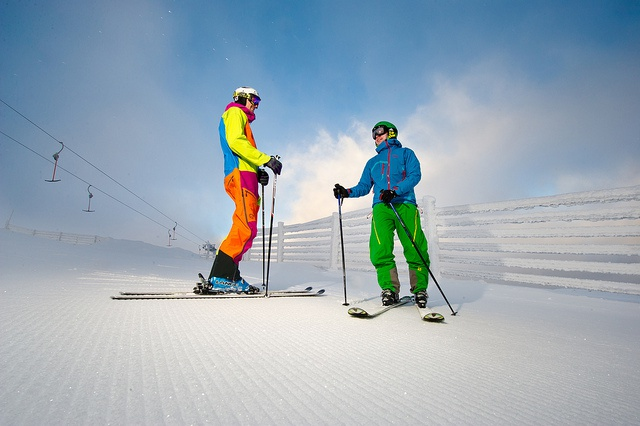Describe the objects in this image and their specific colors. I can see people in blue, teal, green, darkgreen, and black tones, people in blue, yellow, red, black, and orange tones, skis in blue, lightgray, darkgray, black, and gray tones, and skis in blue, lightgray, black, gray, and darkgray tones in this image. 